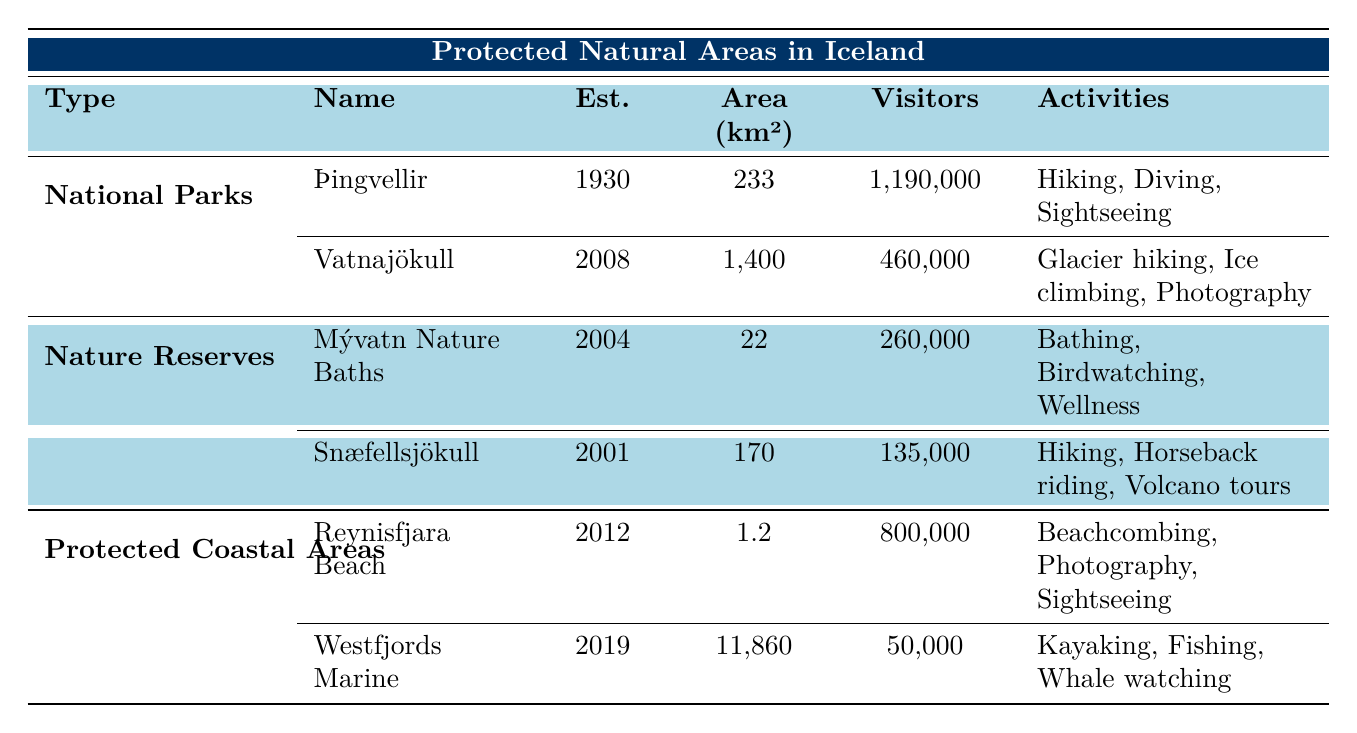What is the total area of all protected natural areas in Iceland? The total area is calculated by adding up the areas of all natural areas listed in the table: 233 + 1400 + 22 + 170 + 1.2 + 11860 = 13486.2 km².
Answer: 13486.2 km² Which protected area has the highest visitor count? By examining the Visitor Count column, Þingvellir National Park has the highest count with 1,190,000 visitors.
Answer: Þingvellir National Park Is the impact of the local economy from visitors to Snæfellsjökull National Park strong? The table states that the Local Economy Impact from Snæfellsjökull National Park is "Weak," so the answer is no.
Answer: No What activities are available in Vatnajökull National Park? The activities for Vatnajökull National Park listed in the table are glacier hiking, ice climbing, and photography.
Answer: Glacier hiking, ice climbing, photography What is the difference in visitor count between Þingvellir National Park and Mývatn Nature Baths? The difference is calculated as 1,190,000 (Þingvellir) - 260,000 (Mývatn) = 930,000.
Answer: 930,000 What year was Reynisfjara Black Sand Beach established? According to the table, Reynisfjara Black Sand Beach was established in 2012.
Answer: 2012 Do all protected natural areas in Iceland have a strong impact on the local economy? Examining the Local Economy Impact for each area, it is clear that not all have a strong impact; for example, the Westfjords Marine Protected Area has a weak impact.
Answer: No How many visitors do the protected coastal areas attract in total? The total number of visitors to the protected coastal areas is calculated by adding their visitor counts: 800,000 (Reynisfjara) + 50,000 (Westfjords) = 850,000.
Answer: 850,000 